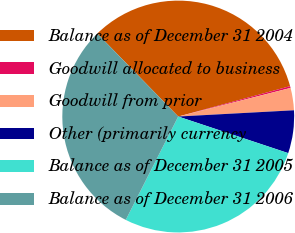<chart> <loc_0><loc_0><loc_500><loc_500><pie_chart><fcel>Balance as of December 31 2004<fcel>Goodwill allocated to business<fcel>Goodwill from prior<fcel>Other (primarily currency<fcel>Balance as of December 31 2005<fcel>Balance as of December 31 2006<nl><fcel>33.08%<fcel>0.25%<fcel>3.11%<fcel>5.97%<fcel>27.36%<fcel>30.22%<nl></chart> 